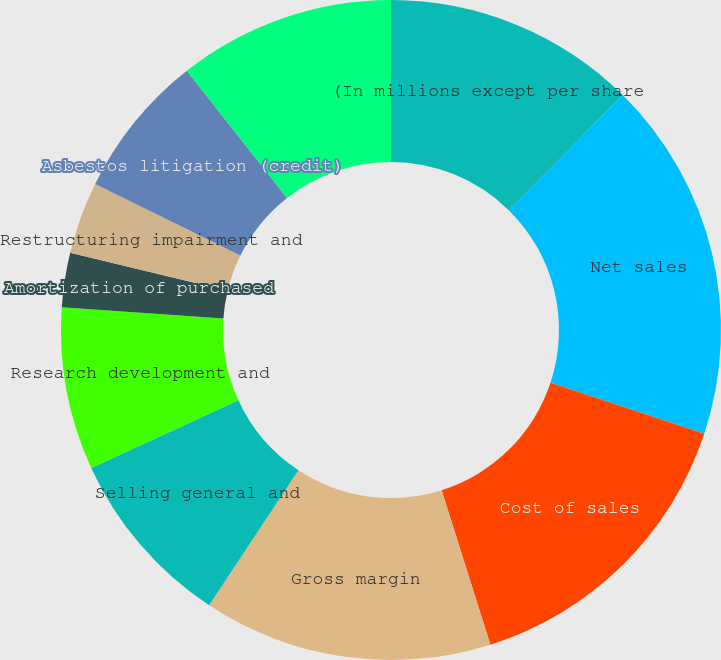<chart> <loc_0><loc_0><loc_500><loc_500><pie_chart><fcel>(In millions except per share<fcel>Net sales<fcel>Cost of sales<fcel>Gross margin<fcel>Selling general and<fcel>Research development and<fcel>Amortization of purchased<fcel>Restructuring impairment and<fcel>Asbestos litigation (credit)<fcel>Operating income<nl><fcel>12.39%<fcel>17.7%<fcel>15.04%<fcel>14.16%<fcel>8.85%<fcel>7.96%<fcel>2.66%<fcel>3.54%<fcel>7.08%<fcel>10.62%<nl></chart> 